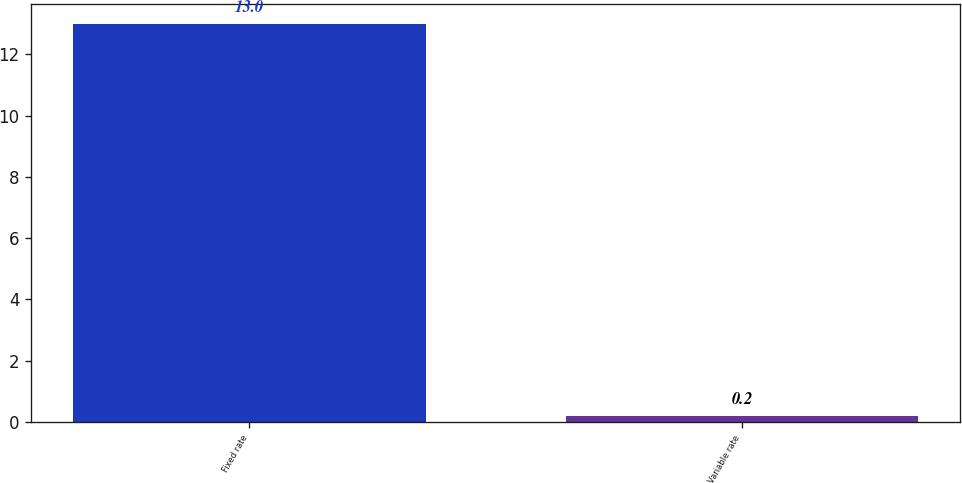Convert chart. <chart><loc_0><loc_0><loc_500><loc_500><bar_chart><fcel>Fixed rate<fcel>Variable rate<nl><fcel>13<fcel>0.2<nl></chart> 